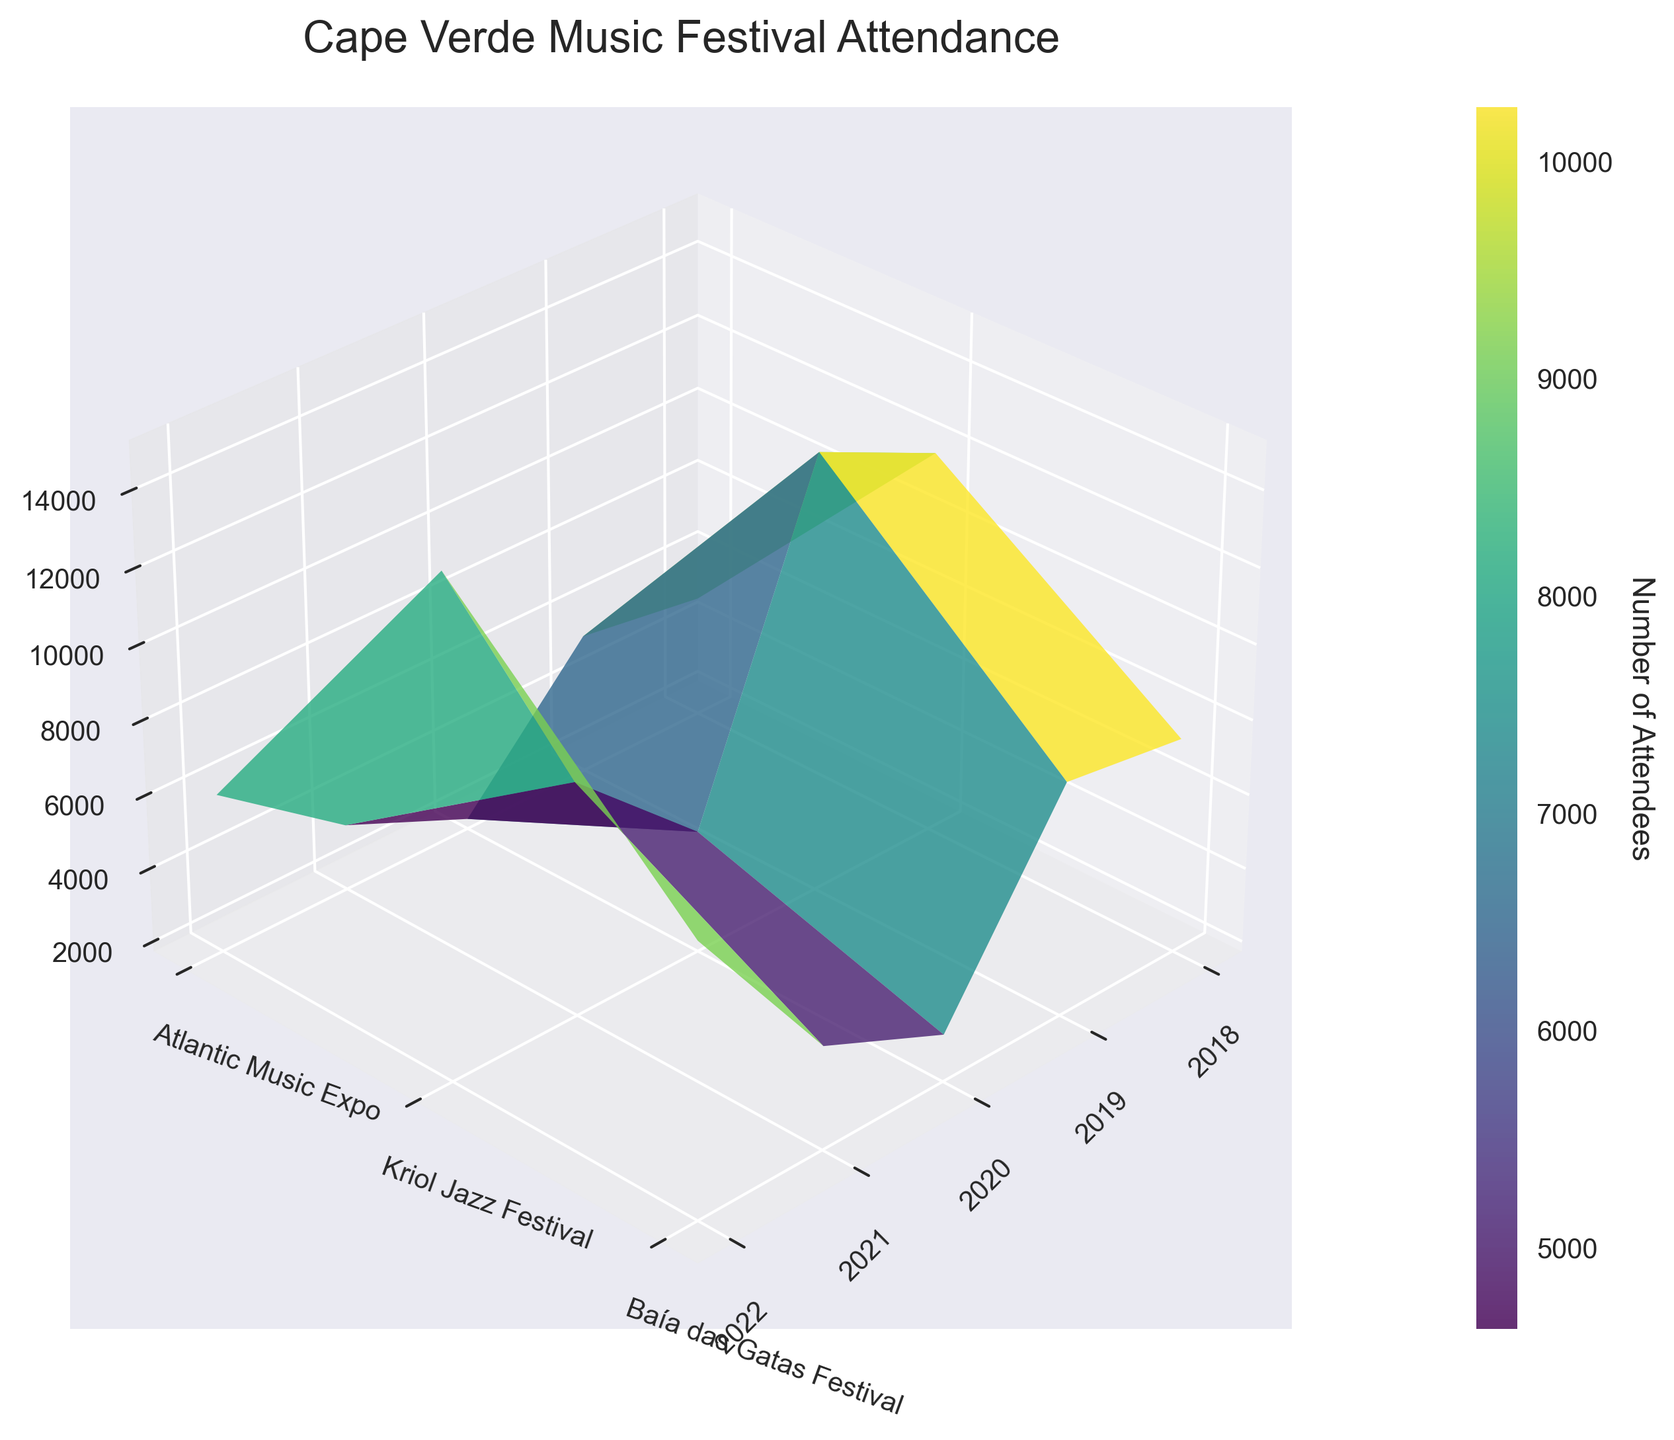Which year had the highest attendance for the Baía das Gatas Festival? First, locate the Baía das Gatas Festival on the y-axis. Then, move along the corresponding row to identify which x-axis year has the highest z-axis value. The highest peak in the z-axis represents the max attendance.
Answer: 2022 How did the number of attendees for the Atlantic Music Expo change from 2018 to 2022? Locate the Atlantic Music Expo row. Compare the z-axis values (number of attendees) at the 2018 and 2022 x-axis positions. Note the difference or incremental change between these years.
Answer: Increased What's the general trend in attendance for the Kriol Jazz Festival from 2018 to 2022? Observe the z-axis peaks along the Kriol Jazz Festival row across the x-axis years. Note if the peaks rise, fall, or fluctuate over time.
Answer: Increasing Which festival saw the steepest decline in attendees in 2020 compared to 2019? Compare the z-axis value for each festival between 2019 and 2020. Identify which festival has the largest drop by observing the highest vertical distance (drop) between these two years.
Answer: Baía das Gatas Festival Compare the attendance of the Kriol Jazz Festival and the Atlantic Music Expo in 2020. Which had more attendees and by how much? Locate both festivals' rows in 2020 along the x-axis. Compare their z-axis values and calculate the difference.
Answer: Kriol Jazz Festival by 1000 How did the attendance for all festivals change from 2018 to 2019? Observe the z-axis values for each festival in 2018 and 2019. Determine if there's an overall increase or decrease by comparing each year's numbers.
Answer: Increased Which festival had the lowest attendance in 2021? Identify the year 2021 on the x-axis. Observe the z-axis value for each festival in that year and find the lowest point.
Answer: Atlantic Music Expo What was the difference in attendance between 2020 and 2021 for the Baía das Gatas Festival? Locate the Baía das Gatas Festival row. Compare the z-axis values between 2020 and 2021 and calculate the difference.
Answer: 3000 In 2022, did the Atlantic Music Expo or Kriol Jazz Festival have a higher attendance? Locate the year 2022 and compare the z-axis values for both festivals. Identify which festival has the higher peak.
Answer: Kriol Jazz Festival Observing the surface plot's color gradient, which festival has the most consistent attendance over the years? Examine the color gradient along each festival's row. The most consistent attendance will show minimal color change over the years.
Answer: Atlantic Music Expo 